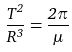Convert formula to latex. <formula><loc_0><loc_0><loc_500><loc_500>\frac { T ^ { 2 } } { R ^ { 3 } } = \frac { 2 \pi } { \mu }</formula> 